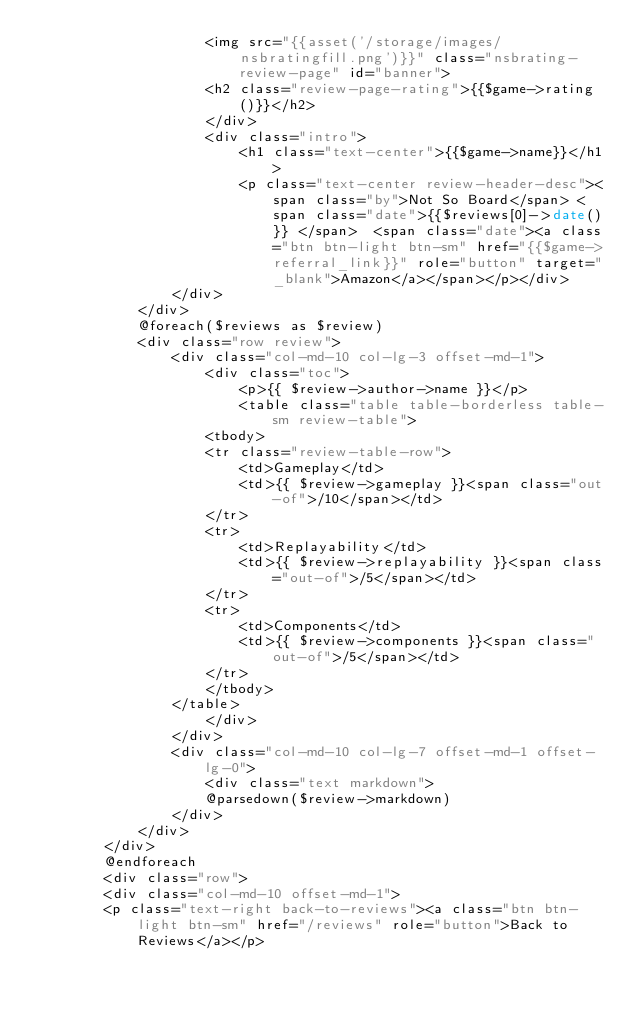Convert code to text. <code><loc_0><loc_0><loc_500><loc_500><_PHP_>                    <img src="{{asset('/storage/images/nsbratingfill.png')}}" class="nsbrating-review-page" id="banner">
                    <h2 class="review-page-rating">{{$game->rating()}}</h2>
                    </div>
                    <div class="intro">
                        <h1 class="text-center">{{$game->name}}</h1>
                        <p class="text-center review-header-desc"><span class="by">Not So Board</span> <span class="date">{{$reviews[0]->date()}} </span>  <span class="date"><a class="btn btn-light btn-sm" href="{{$game->referral_link}}" role="button" target="_blank">Amazon</a></span></p></div>
                </div>
            </div>
            @foreach($reviews as $review)
            <div class="row review">
                <div class="col-md-10 col-lg-3 offset-md-1">
                    <div class="toc">
                        <p>{{ $review->author->name }}</p>
                        <table class="table table-borderless table-sm review-table"> 
                    <tbody>
                    <tr class="review-table-row">
                        <td>Gameplay</td>
                        <td>{{ $review->gameplay }}<span class="out-of">/10</span></td>
                    </tr>
                    <tr>
                        <td>Replayability</td>
                        <td>{{ $review->replayability }}<span class="out-of">/5</span></td>
                    </tr>
                    <tr>
                        <td>Components</td>
                        <td>{{ $review->components }}<span class="out-of">/5</span></td>
                    </tr>
                    </tbody>
                </table>
                    </div>
                </div>
                <div class="col-md-10 col-lg-7 offset-md-1 offset-lg-0">
                    <div class="text markdown">
                    @parsedown($review->markdown)
                </div>
            </div>
        </div>
        @endforeach
        <div class="row">
        <div class="col-md-10 offset-md-1">
        <p class="text-right back-to-reviews"><a class="btn btn-light btn-sm" href="/reviews" role="button">Back to Reviews</a></p></code> 